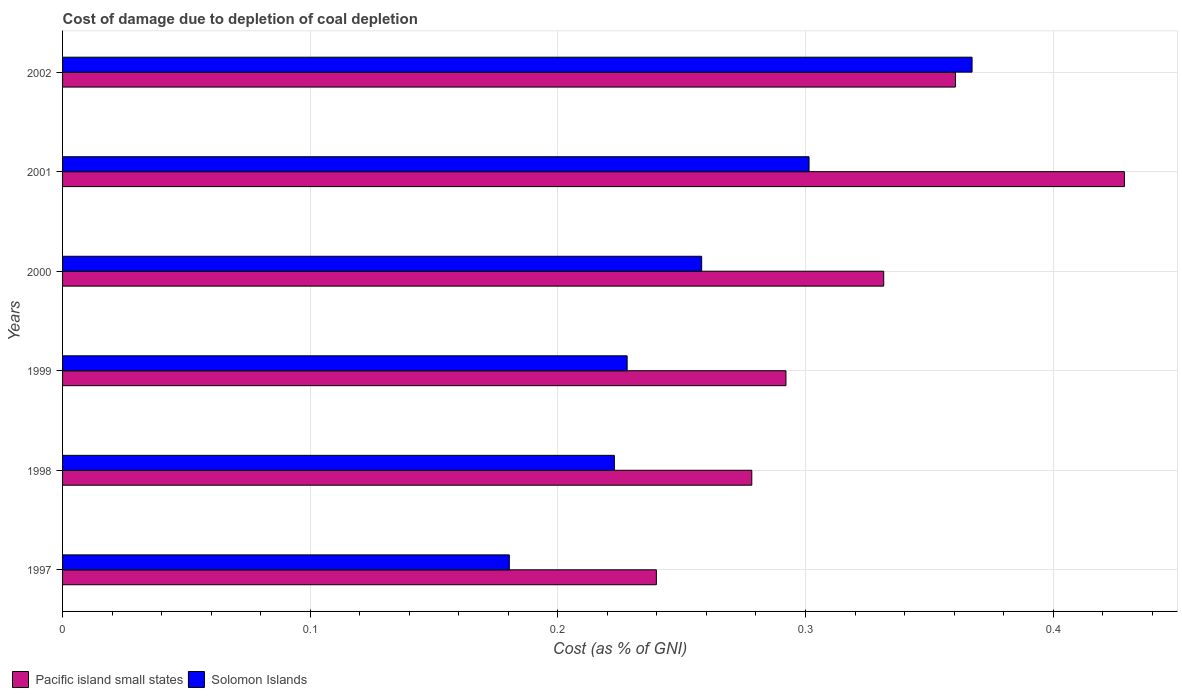How many groups of bars are there?
Ensure brevity in your answer.  6. Are the number of bars per tick equal to the number of legend labels?
Provide a succinct answer. Yes. Are the number of bars on each tick of the Y-axis equal?
Give a very brief answer. Yes. How many bars are there on the 3rd tick from the top?
Your response must be concise. 2. How many bars are there on the 6th tick from the bottom?
Offer a terse response. 2. What is the label of the 4th group of bars from the top?
Your response must be concise. 1999. In how many cases, is the number of bars for a given year not equal to the number of legend labels?
Offer a very short reply. 0. What is the cost of damage caused due to coal depletion in Pacific island small states in 1999?
Your answer should be very brief. 0.29. Across all years, what is the maximum cost of damage caused due to coal depletion in Solomon Islands?
Offer a very short reply. 0.37. Across all years, what is the minimum cost of damage caused due to coal depletion in Solomon Islands?
Offer a terse response. 0.18. In which year was the cost of damage caused due to coal depletion in Pacific island small states maximum?
Provide a short and direct response. 2001. In which year was the cost of damage caused due to coal depletion in Solomon Islands minimum?
Your answer should be compact. 1997. What is the total cost of damage caused due to coal depletion in Solomon Islands in the graph?
Offer a very short reply. 1.56. What is the difference between the cost of damage caused due to coal depletion in Pacific island small states in 1997 and that in 1999?
Keep it short and to the point. -0.05. What is the difference between the cost of damage caused due to coal depletion in Pacific island small states in 1998 and the cost of damage caused due to coal depletion in Solomon Islands in 1999?
Your response must be concise. 0.05. What is the average cost of damage caused due to coal depletion in Solomon Islands per year?
Provide a succinct answer. 0.26. In the year 2000, what is the difference between the cost of damage caused due to coal depletion in Solomon Islands and cost of damage caused due to coal depletion in Pacific island small states?
Provide a short and direct response. -0.07. What is the ratio of the cost of damage caused due to coal depletion in Solomon Islands in 2000 to that in 2002?
Provide a short and direct response. 0.7. Is the cost of damage caused due to coal depletion in Solomon Islands in 1998 less than that in 2000?
Your answer should be compact. Yes. What is the difference between the highest and the second highest cost of damage caused due to coal depletion in Solomon Islands?
Your answer should be compact. 0.07. What is the difference between the highest and the lowest cost of damage caused due to coal depletion in Solomon Islands?
Give a very brief answer. 0.19. Is the sum of the cost of damage caused due to coal depletion in Solomon Islands in 1997 and 1999 greater than the maximum cost of damage caused due to coal depletion in Pacific island small states across all years?
Offer a terse response. No. What does the 1st bar from the top in 2000 represents?
Make the answer very short. Solomon Islands. What does the 1st bar from the bottom in 2000 represents?
Ensure brevity in your answer.  Pacific island small states. How many years are there in the graph?
Your response must be concise. 6. What is the difference between two consecutive major ticks on the X-axis?
Keep it short and to the point. 0.1. Where does the legend appear in the graph?
Your answer should be compact. Bottom left. What is the title of the graph?
Provide a short and direct response. Cost of damage due to depletion of coal depletion. Does "Euro area" appear as one of the legend labels in the graph?
Offer a very short reply. No. What is the label or title of the X-axis?
Keep it short and to the point. Cost (as % of GNI). What is the Cost (as % of GNI) of Pacific island small states in 1997?
Offer a very short reply. 0.24. What is the Cost (as % of GNI) in Solomon Islands in 1997?
Keep it short and to the point. 0.18. What is the Cost (as % of GNI) of Pacific island small states in 1998?
Keep it short and to the point. 0.28. What is the Cost (as % of GNI) in Solomon Islands in 1998?
Give a very brief answer. 0.22. What is the Cost (as % of GNI) in Pacific island small states in 1999?
Keep it short and to the point. 0.29. What is the Cost (as % of GNI) of Solomon Islands in 1999?
Offer a terse response. 0.23. What is the Cost (as % of GNI) of Pacific island small states in 2000?
Give a very brief answer. 0.33. What is the Cost (as % of GNI) of Solomon Islands in 2000?
Your answer should be compact. 0.26. What is the Cost (as % of GNI) of Pacific island small states in 2001?
Provide a succinct answer. 0.43. What is the Cost (as % of GNI) in Solomon Islands in 2001?
Provide a succinct answer. 0.3. What is the Cost (as % of GNI) of Pacific island small states in 2002?
Your response must be concise. 0.36. What is the Cost (as % of GNI) of Solomon Islands in 2002?
Provide a succinct answer. 0.37. Across all years, what is the maximum Cost (as % of GNI) of Pacific island small states?
Your answer should be compact. 0.43. Across all years, what is the maximum Cost (as % of GNI) in Solomon Islands?
Provide a short and direct response. 0.37. Across all years, what is the minimum Cost (as % of GNI) in Pacific island small states?
Offer a terse response. 0.24. Across all years, what is the minimum Cost (as % of GNI) of Solomon Islands?
Provide a short and direct response. 0.18. What is the total Cost (as % of GNI) in Pacific island small states in the graph?
Offer a very short reply. 1.93. What is the total Cost (as % of GNI) in Solomon Islands in the graph?
Offer a very short reply. 1.56. What is the difference between the Cost (as % of GNI) of Pacific island small states in 1997 and that in 1998?
Ensure brevity in your answer.  -0.04. What is the difference between the Cost (as % of GNI) of Solomon Islands in 1997 and that in 1998?
Your answer should be very brief. -0.04. What is the difference between the Cost (as % of GNI) in Pacific island small states in 1997 and that in 1999?
Your answer should be very brief. -0.05. What is the difference between the Cost (as % of GNI) in Solomon Islands in 1997 and that in 1999?
Your answer should be very brief. -0.05. What is the difference between the Cost (as % of GNI) in Pacific island small states in 1997 and that in 2000?
Your answer should be very brief. -0.09. What is the difference between the Cost (as % of GNI) of Solomon Islands in 1997 and that in 2000?
Your answer should be compact. -0.08. What is the difference between the Cost (as % of GNI) of Pacific island small states in 1997 and that in 2001?
Ensure brevity in your answer.  -0.19. What is the difference between the Cost (as % of GNI) in Solomon Islands in 1997 and that in 2001?
Keep it short and to the point. -0.12. What is the difference between the Cost (as % of GNI) in Pacific island small states in 1997 and that in 2002?
Provide a short and direct response. -0.12. What is the difference between the Cost (as % of GNI) of Solomon Islands in 1997 and that in 2002?
Keep it short and to the point. -0.19. What is the difference between the Cost (as % of GNI) in Pacific island small states in 1998 and that in 1999?
Make the answer very short. -0.01. What is the difference between the Cost (as % of GNI) in Solomon Islands in 1998 and that in 1999?
Provide a short and direct response. -0.01. What is the difference between the Cost (as % of GNI) of Pacific island small states in 1998 and that in 2000?
Provide a short and direct response. -0.05. What is the difference between the Cost (as % of GNI) of Solomon Islands in 1998 and that in 2000?
Make the answer very short. -0.04. What is the difference between the Cost (as % of GNI) of Pacific island small states in 1998 and that in 2001?
Make the answer very short. -0.15. What is the difference between the Cost (as % of GNI) in Solomon Islands in 1998 and that in 2001?
Your answer should be very brief. -0.08. What is the difference between the Cost (as % of GNI) in Pacific island small states in 1998 and that in 2002?
Make the answer very short. -0.08. What is the difference between the Cost (as % of GNI) in Solomon Islands in 1998 and that in 2002?
Give a very brief answer. -0.14. What is the difference between the Cost (as % of GNI) in Pacific island small states in 1999 and that in 2000?
Offer a terse response. -0.04. What is the difference between the Cost (as % of GNI) of Solomon Islands in 1999 and that in 2000?
Offer a very short reply. -0.03. What is the difference between the Cost (as % of GNI) in Pacific island small states in 1999 and that in 2001?
Your answer should be very brief. -0.14. What is the difference between the Cost (as % of GNI) in Solomon Islands in 1999 and that in 2001?
Offer a very short reply. -0.07. What is the difference between the Cost (as % of GNI) of Pacific island small states in 1999 and that in 2002?
Ensure brevity in your answer.  -0.07. What is the difference between the Cost (as % of GNI) of Solomon Islands in 1999 and that in 2002?
Make the answer very short. -0.14. What is the difference between the Cost (as % of GNI) of Pacific island small states in 2000 and that in 2001?
Offer a very short reply. -0.1. What is the difference between the Cost (as % of GNI) in Solomon Islands in 2000 and that in 2001?
Ensure brevity in your answer.  -0.04. What is the difference between the Cost (as % of GNI) of Pacific island small states in 2000 and that in 2002?
Ensure brevity in your answer.  -0.03. What is the difference between the Cost (as % of GNI) of Solomon Islands in 2000 and that in 2002?
Provide a short and direct response. -0.11. What is the difference between the Cost (as % of GNI) in Pacific island small states in 2001 and that in 2002?
Your response must be concise. 0.07. What is the difference between the Cost (as % of GNI) of Solomon Islands in 2001 and that in 2002?
Provide a short and direct response. -0.07. What is the difference between the Cost (as % of GNI) in Pacific island small states in 1997 and the Cost (as % of GNI) in Solomon Islands in 1998?
Provide a short and direct response. 0.02. What is the difference between the Cost (as % of GNI) of Pacific island small states in 1997 and the Cost (as % of GNI) of Solomon Islands in 1999?
Provide a short and direct response. 0.01. What is the difference between the Cost (as % of GNI) of Pacific island small states in 1997 and the Cost (as % of GNI) of Solomon Islands in 2000?
Your response must be concise. -0.02. What is the difference between the Cost (as % of GNI) in Pacific island small states in 1997 and the Cost (as % of GNI) in Solomon Islands in 2001?
Offer a very short reply. -0.06. What is the difference between the Cost (as % of GNI) in Pacific island small states in 1997 and the Cost (as % of GNI) in Solomon Islands in 2002?
Ensure brevity in your answer.  -0.13. What is the difference between the Cost (as % of GNI) in Pacific island small states in 1998 and the Cost (as % of GNI) in Solomon Islands in 1999?
Provide a succinct answer. 0.05. What is the difference between the Cost (as % of GNI) in Pacific island small states in 1998 and the Cost (as % of GNI) in Solomon Islands in 2000?
Offer a very short reply. 0.02. What is the difference between the Cost (as % of GNI) in Pacific island small states in 1998 and the Cost (as % of GNI) in Solomon Islands in 2001?
Give a very brief answer. -0.02. What is the difference between the Cost (as % of GNI) of Pacific island small states in 1998 and the Cost (as % of GNI) of Solomon Islands in 2002?
Ensure brevity in your answer.  -0.09. What is the difference between the Cost (as % of GNI) in Pacific island small states in 1999 and the Cost (as % of GNI) in Solomon Islands in 2000?
Provide a short and direct response. 0.03. What is the difference between the Cost (as % of GNI) of Pacific island small states in 1999 and the Cost (as % of GNI) of Solomon Islands in 2001?
Provide a short and direct response. -0.01. What is the difference between the Cost (as % of GNI) in Pacific island small states in 1999 and the Cost (as % of GNI) in Solomon Islands in 2002?
Provide a succinct answer. -0.08. What is the difference between the Cost (as % of GNI) in Pacific island small states in 2000 and the Cost (as % of GNI) in Solomon Islands in 2001?
Offer a terse response. 0.03. What is the difference between the Cost (as % of GNI) of Pacific island small states in 2000 and the Cost (as % of GNI) of Solomon Islands in 2002?
Offer a very short reply. -0.04. What is the difference between the Cost (as % of GNI) in Pacific island small states in 2001 and the Cost (as % of GNI) in Solomon Islands in 2002?
Your response must be concise. 0.06. What is the average Cost (as % of GNI) of Pacific island small states per year?
Provide a short and direct response. 0.32. What is the average Cost (as % of GNI) of Solomon Islands per year?
Offer a very short reply. 0.26. In the year 1997, what is the difference between the Cost (as % of GNI) in Pacific island small states and Cost (as % of GNI) in Solomon Islands?
Ensure brevity in your answer.  0.06. In the year 1998, what is the difference between the Cost (as % of GNI) in Pacific island small states and Cost (as % of GNI) in Solomon Islands?
Your answer should be compact. 0.06. In the year 1999, what is the difference between the Cost (as % of GNI) of Pacific island small states and Cost (as % of GNI) of Solomon Islands?
Ensure brevity in your answer.  0.06. In the year 2000, what is the difference between the Cost (as % of GNI) of Pacific island small states and Cost (as % of GNI) of Solomon Islands?
Your answer should be very brief. 0.07. In the year 2001, what is the difference between the Cost (as % of GNI) in Pacific island small states and Cost (as % of GNI) in Solomon Islands?
Your answer should be compact. 0.13. In the year 2002, what is the difference between the Cost (as % of GNI) in Pacific island small states and Cost (as % of GNI) in Solomon Islands?
Give a very brief answer. -0.01. What is the ratio of the Cost (as % of GNI) in Pacific island small states in 1997 to that in 1998?
Keep it short and to the point. 0.86. What is the ratio of the Cost (as % of GNI) in Solomon Islands in 1997 to that in 1998?
Keep it short and to the point. 0.81. What is the ratio of the Cost (as % of GNI) of Pacific island small states in 1997 to that in 1999?
Make the answer very short. 0.82. What is the ratio of the Cost (as % of GNI) of Solomon Islands in 1997 to that in 1999?
Your response must be concise. 0.79. What is the ratio of the Cost (as % of GNI) of Pacific island small states in 1997 to that in 2000?
Offer a terse response. 0.72. What is the ratio of the Cost (as % of GNI) of Solomon Islands in 1997 to that in 2000?
Give a very brief answer. 0.7. What is the ratio of the Cost (as % of GNI) in Pacific island small states in 1997 to that in 2001?
Make the answer very short. 0.56. What is the ratio of the Cost (as % of GNI) in Solomon Islands in 1997 to that in 2001?
Your response must be concise. 0.6. What is the ratio of the Cost (as % of GNI) of Pacific island small states in 1997 to that in 2002?
Your response must be concise. 0.67. What is the ratio of the Cost (as % of GNI) of Solomon Islands in 1997 to that in 2002?
Your answer should be compact. 0.49. What is the ratio of the Cost (as % of GNI) of Pacific island small states in 1998 to that in 1999?
Offer a very short reply. 0.95. What is the ratio of the Cost (as % of GNI) of Solomon Islands in 1998 to that in 1999?
Ensure brevity in your answer.  0.98. What is the ratio of the Cost (as % of GNI) of Pacific island small states in 1998 to that in 2000?
Your answer should be compact. 0.84. What is the ratio of the Cost (as % of GNI) in Solomon Islands in 1998 to that in 2000?
Give a very brief answer. 0.86. What is the ratio of the Cost (as % of GNI) of Pacific island small states in 1998 to that in 2001?
Provide a succinct answer. 0.65. What is the ratio of the Cost (as % of GNI) in Solomon Islands in 1998 to that in 2001?
Provide a succinct answer. 0.74. What is the ratio of the Cost (as % of GNI) of Pacific island small states in 1998 to that in 2002?
Your answer should be very brief. 0.77. What is the ratio of the Cost (as % of GNI) in Solomon Islands in 1998 to that in 2002?
Give a very brief answer. 0.61. What is the ratio of the Cost (as % of GNI) in Pacific island small states in 1999 to that in 2000?
Keep it short and to the point. 0.88. What is the ratio of the Cost (as % of GNI) in Solomon Islands in 1999 to that in 2000?
Your answer should be very brief. 0.88. What is the ratio of the Cost (as % of GNI) of Pacific island small states in 1999 to that in 2001?
Offer a terse response. 0.68. What is the ratio of the Cost (as % of GNI) in Solomon Islands in 1999 to that in 2001?
Give a very brief answer. 0.76. What is the ratio of the Cost (as % of GNI) in Pacific island small states in 1999 to that in 2002?
Give a very brief answer. 0.81. What is the ratio of the Cost (as % of GNI) of Solomon Islands in 1999 to that in 2002?
Offer a terse response. 0.62. What is the ratio of the Cost (as % of GNI) in Pacific island small states in 2000 to that in 2001?
Provide a succinct answer. 0.77. What is the ratio of the Cost (as % of GNI) of Solomon Islands in 2000 to that in 2001?
Your answer should be compact. 0.86. What is the ratio of the Cost (as % of GNI) of Pacific island small states in 2000 to that in 2002?
Your answer should be very brief. 0.92. What is the ratio of the Cost (as % of GNI) of Solomon Islands in 2000 to that in 2002?
Ensure brevity in your answer.  0.7. What is the ratio of the Cost (as % of GNI) in Pacific island small states in 2001 to that in 2002?
Your answer should be very brief. 1.19. What is the ratio of the Cost (as % of GNI) in Solomon Islands in 2001 to that in 2002?
Keep it short and to the point. 0.82. What is the difference between the highest and the second highest Cost (as % of GNI) in Pacific island small states?
Make the answer very short. 0.07. What is the difference between the highest and the second highest Cost (as % of GNI) in Solomon Islands?
Your response must be concise. 0.07. What is the difference between the highest and the lowest Cost (as % of GNI) in Pacific island small states?
Offer a very short reply. 0.19. What is the difference between the highest and the lowest Cost (as % of GNI) in Solomon Islands?
Keep it short and to the point. 0.19. 